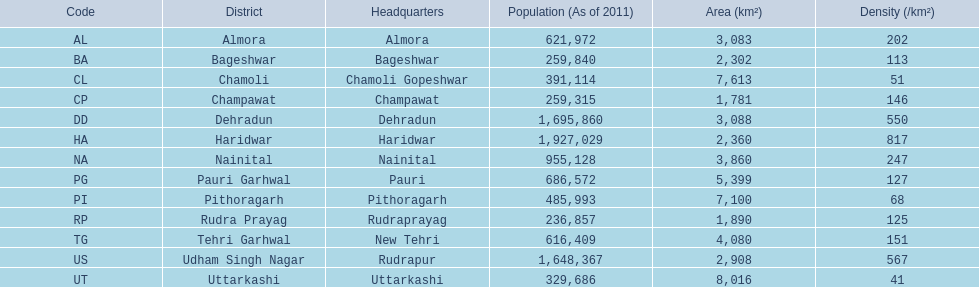When someone's primary residence is in almora, what district are they associated with? Almora. 